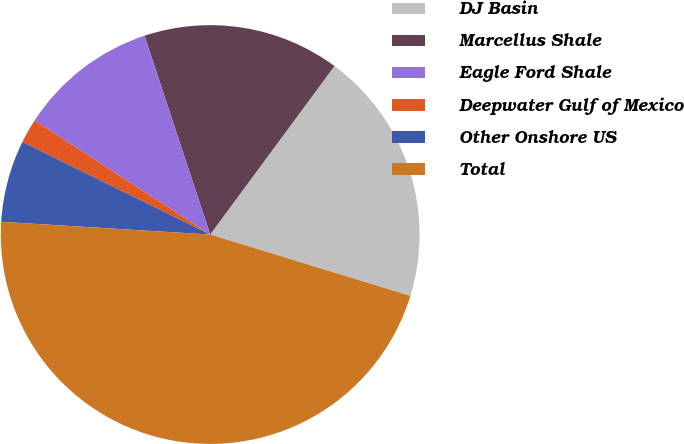Convert chart. <chart><loc_0><loc_0><loc_500><loc_500><pie_chart><fcel>DJ Basin<fcel>Marcellus Shale<fcel>Eagle Ford Shale<fcel>Deepwater Gulf of Mexico<fcel>Other Onshore US<fcel>Total<nl><fcel>19.62%<fcel>15.19%<fcel>10.75%<fcel>1.88%<fcel>6.32%<fcel>46.23%<nl></chart> 